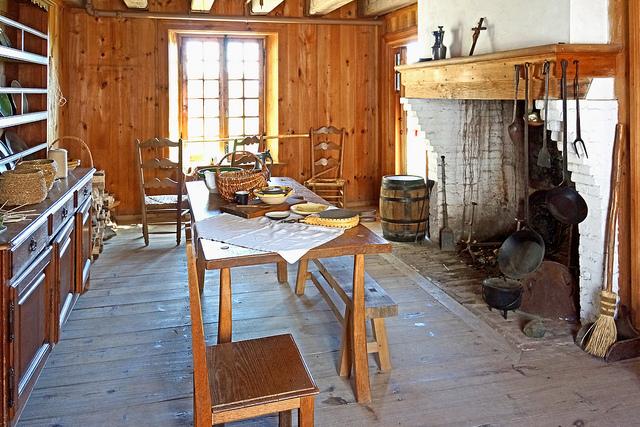How old is this house?
Concise answer only. Old. Where is the cross made of wood?
Quick response, please. Mantle. How many chairs are in this room?
Keep it brief. 3. 